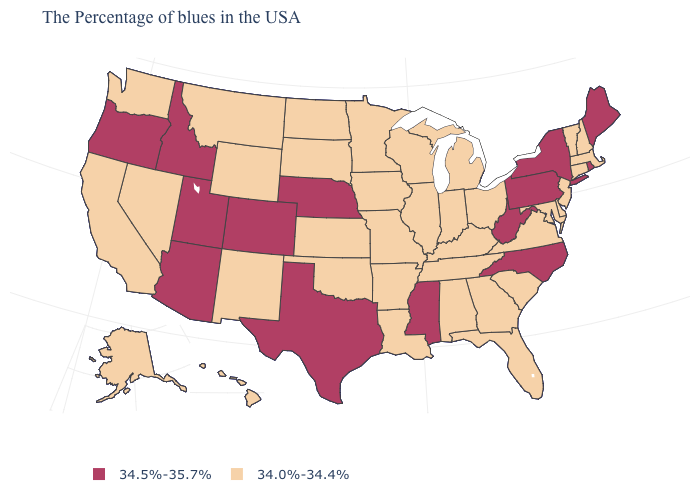Which states have the lowest value in the USA?
Answer briefly. Massachusetts, New Hampshire, Vermont, Connecticut, New Jersey, Delaware, Maryland, Virginia, South Carolina, Ohio, Florida, Georgia, Michigan, Kentucky, Indiana, Alabama, Tennessee, Wisconsin, Illinois, Louisiana, Missouri, Arkansas, Minnesota, Iowa, Kansas, Oklahoma, South Dakota, North Dakota, Wyoming, New Mexico, Montana, Nevada, California, Washington, Alaska, Hawaii. Is the legend a continuous bar?
Be succinct. No. Name the states that have a value in the range 34.0%-34.4%?
Short answer required. Massachusetts, New Hampshire, Vermont, Connecticut, New Jersey, Delaware, Maryland, Virginia, South Carolina, Ohio, Florida, Georgia, Michigan, Kentucky, Indiana, Alabama, Tennessee, Wisconsin, Illinois, Louisiana, Missouri, Arkansas, Minnesota, Iowa, Kansas, Oklahoma, South Dakota, North Dakota, Wyoming, New Mexico, Montana, Nevada, California, Washington, Alaska, Hawaii. What is the value of North Carolina?
Write a very short answer. 34.5%-35.7%. What is the value of Alaska?
Be succinct. 34.0%-34.4%. Among the states that border Missouri , does Nebraska have the lowest value?
Short answer required. No. What is the value of West Virginia?
Keep it brief. 34.5%-35.7%. What is the highest value in states that border Georgia?
Be succinct. 34.5%-35.7%. What is the value of Nevada?
Answer briefly. 34.0%-34.4%. What is the lowest value in the West?
Write a very short answer. 34.0%-34.4%. What is the lowest value in states that border Alabama?
Write a very short answer. 34.0%-34.4%. Name the states that have a value in the range 34.0%-34.4%?
Give a very brief answer. Massachusetts, New Hampshire, Vermont, Connecticut, New Jersey, Delaware, Maryland, Virginia, South Carolina, Ohio, Florida, Georgia, Michigan, Kentucky, Indiana, Alabama, Tennessee, Wisconsin, Illinois, Louisiana, Missouri, Arkansas, Minnesota, Iowa, Kansas, Oklahoma, South Dakota, North Dakota, Wyoming, New Mexico, Montana, Nevada, California, Washington, Alaska, Hawaii. What is the lowest value in the West?
Write a very short answer. 34.0%-34.4%. Which states have the highest value in the USA?
Short answer required. Maine, Rhode Island, New York, Pennsylvania, North Carolina, West Virginia, Mississippi, Nebraska, Texas, Colorado, Utah, Arizona, Idaho, Oregon. Name the states that have a value in the range 34.0%-34.4%?
Keep it brief. Massachusetts, New Hampshire, Vermont, Connecticut, New Jersey, Delaware, Maryland, Virginia, South Carolina, Ohio, Florida, Georgia, Michigan, Kentucky, Indiana, Alabama, Tennessee, Wisconsin, Illinois, Louisiana, Missouri, Arkansas, Minnesota, Iowa, Kansas, Oklahoma, South Dakota, North Dakota, Wyoming, New Mexico, Montana, Nevada, California, Washington, Alaska, Hawaii. 